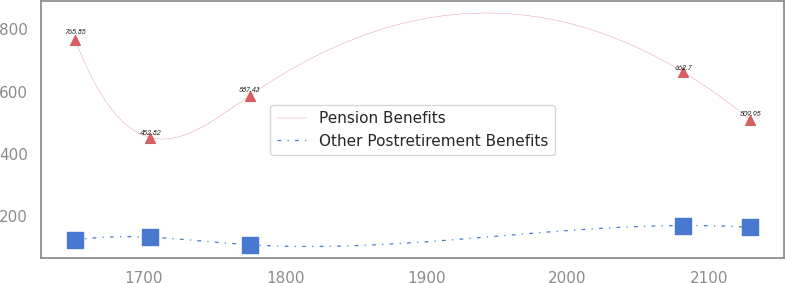Convert chart. <chart><loc_0><loc_0><loc_500><loc_500><line_chart><ecel><fcel>Pension Benefits<fcel>Other Postretirement Benefits<nl><fcel>1651.35<fcel>765.85<fcel>124.66<nl><fcel>1704.51<fcel>452.82<fcel>133.37<nl><fcel>1774.84<fcel>587.43<fcel>109.52<nl><fcel>2081.78<fcel>662.7<fcel>171.14<nl><fcel>2129.27<fcel>509.95<fcel>165.19<nl></chart> 